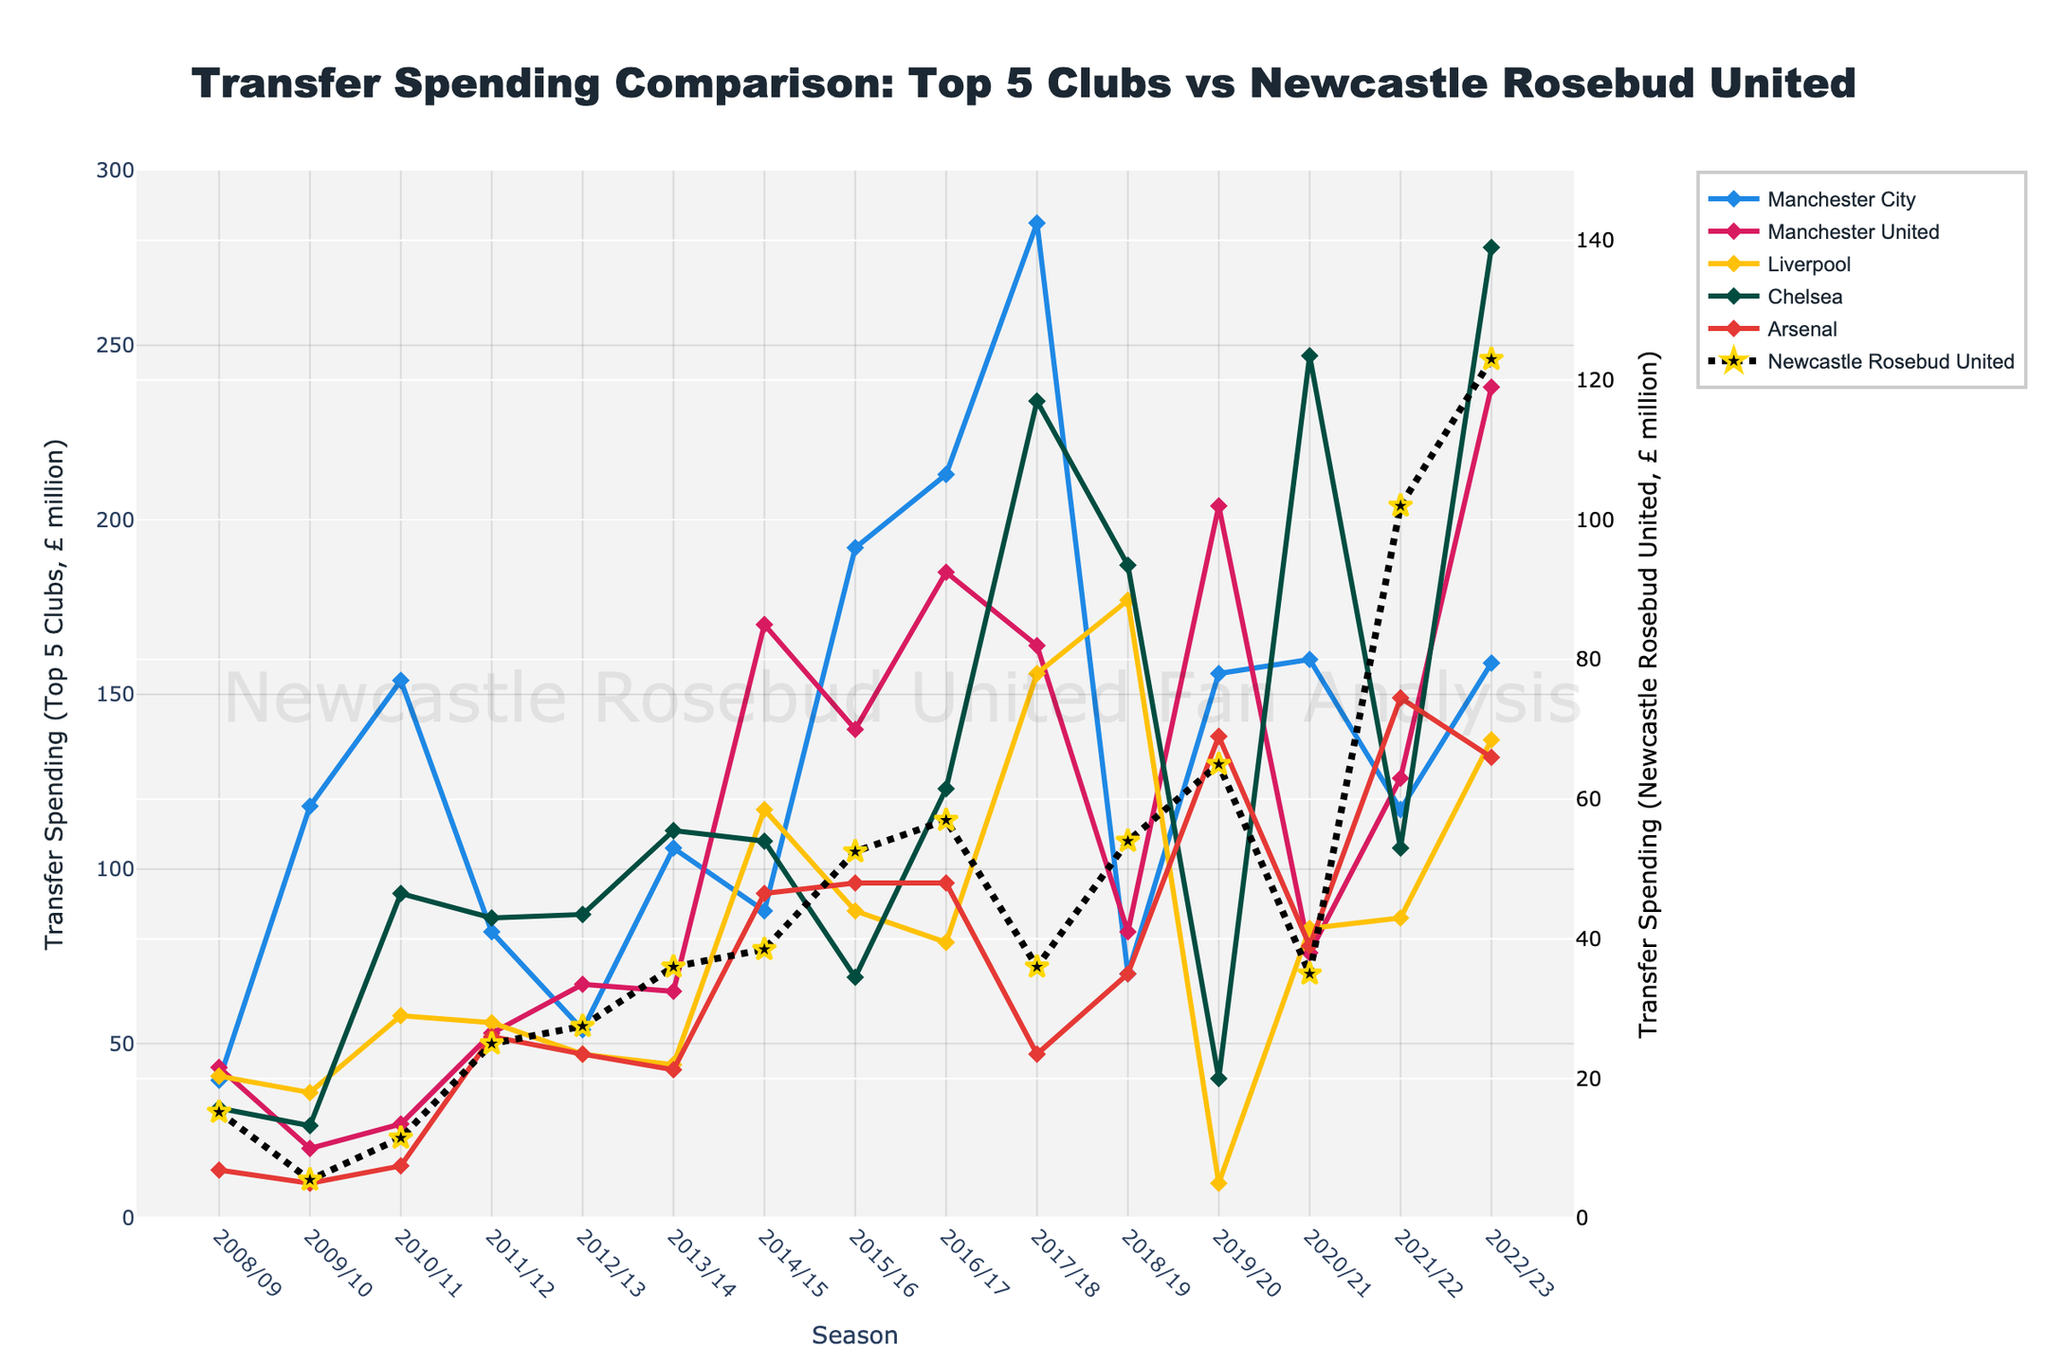Which club had the highest transfer spending in the 2017/18 season? The 2017/18 season shows that Manchester City had the highest transfer spending, indicated by the topmost line in that season.
Answer: Manchester City How did Newcastle Rosebud United's transfer spending in 2015/16 compare to their spending in 2022/23? To compare, look at the data points for Newcastle Rosebud United in both seasons. In 2015/16, their spending was £52.5 million, while in 2022/23, it was £123.0 million. This shows a significant increase.
Answer: 2015/16: £52.5 million, 2022/23: £123.0 million What is the average transfer spending of Arsenal over the 15 years? Sum up Arsenal's spending from 2008/09 to 2022/23 and then divide by the number of seasons (15). (13.8 + 10.0 + 15.0 + 52.0 + 47.0 + 42.5 + 93.0 + 96.0 + 96.0 + 47.0 + 70.0 + 138.0 + 78.0 + 149.0 + 132.0) / 15.
Answer: £70.5 million Which season saw the highest transfer spending for Chelsea? By examining the peaks of Chelsea's line in the plot, the 2020/21 season shows the highest transfer spending at £247.0 million.
Answer: 2020/21 Compare the transfer spending of Liverpool and Manchester United in 2010/11. In 2010/11, Liverpool's spending (£58.0 million) was greater than Manchester United's (£27.0 million), visually corresponding to heights in the plotted points.
Answer: Liverpool: £58.0 million, Manchester United: £27.0 million What was the trend in Newcastle Rosebud United's transfer spending from 2008/09 to 2022/23? Observing the dotted line representing Newcastle Rosebud United, the trend shows an overall increase with fluctuations, starting at £15.2 million in 2008/09 and peaking at £123.0 million in 2022/23.
Answer: Increasing trend Which club had the most consistent transfer spending over the 15 years? Arsenal's line appears relatively stable with less variance compared to others; no extreme peaks or valleys stand out.
Answer: Arsenal What is the total transfer spending of Newcastle Rosebud United across the 15 seasons? Sum up Newcastle Rosebud United's spending for all seasons: 15.2 + 5.5 + 11.5 + 25.0 + 27.5 + 36.0 + 38.5 + 52.5 + 57.0 + 36.0 + 54.0 + 65.0 + 35.0 + 102.0 + 123.0. The total is £683.7 million.
Answer: £683.7 million During which season did Newcastle Rosebud United spend the most, and how does it compare with Liverpool's spending that same season? Newcastle Rosebud United spent the most in the 2022/23 season (£123.0 million), and Liverpool spent £137.0 million in the same season.
Answer: Newcastle Rosebud United: £123.0 million, Liverpool: £137.0 million How does the peak spending of Manchester City (£285.0 million in 2017/18) compare to Newcastle Rosebud United's peak spending? Manchester City's peak was £285.0 million in 2017/18, while Newcastle Rosebud United's peak was £123.0 million in 2022/23. Manchester City's peak was over twice as high.
Answer: Manchester City: £285.0 million, Newcastle Rosebud United: £123.0 million 